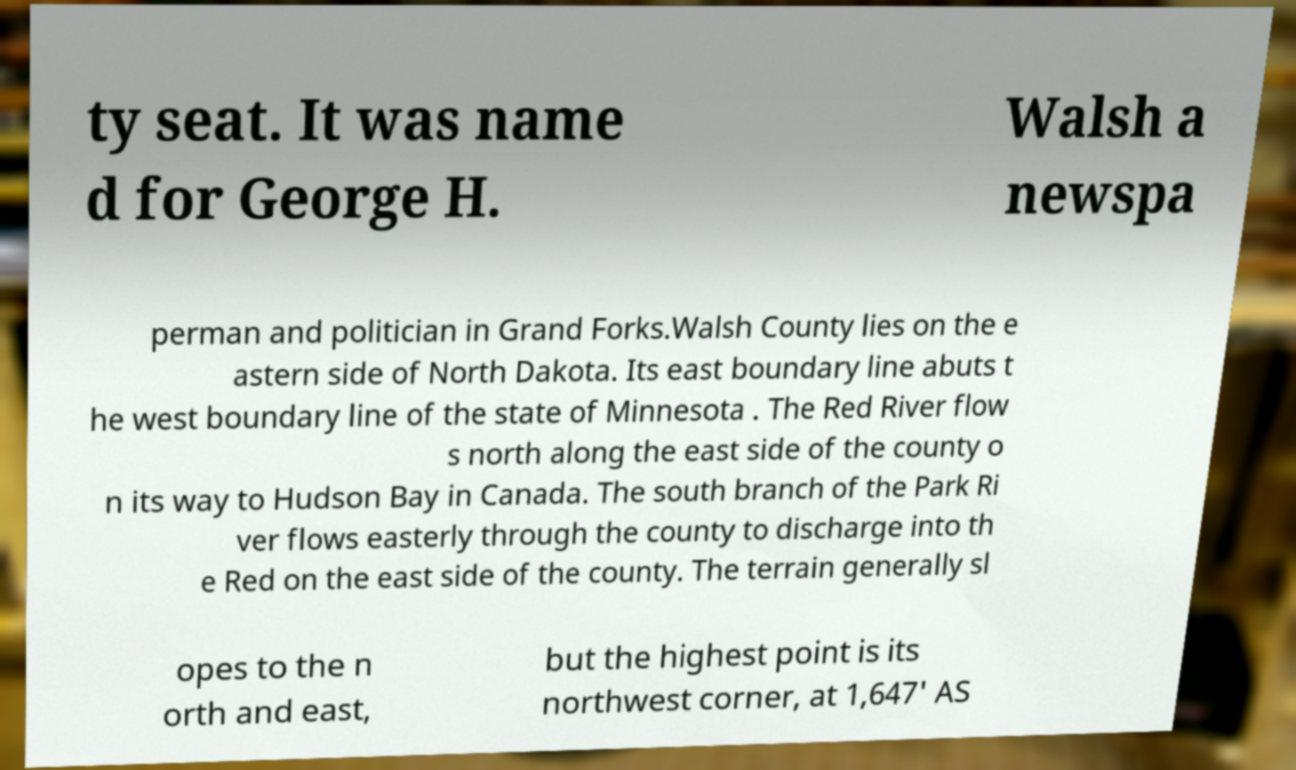Can you read and provide the text displayed in the image?This photo seems to have some interesting text. Can you extract and type it out for me? ty seat. It was name d for George H. Walsh a newspa perman and politician in Grand Forks.Walsh County lies on the e astern side of North Dakota. Its east boundary line abuts t he west boundary line of the state of Minnesota . The Red River flow s north along the east side of the county o n its way to Hudson Bay in Canada. The south branch of the Park Ri ver flows easterly through the county to discharge into th e Red on the east side of the county. The terrain generally sl opes to the n orth and east, but the highest point is its northwest corner, at 1,647' AS 